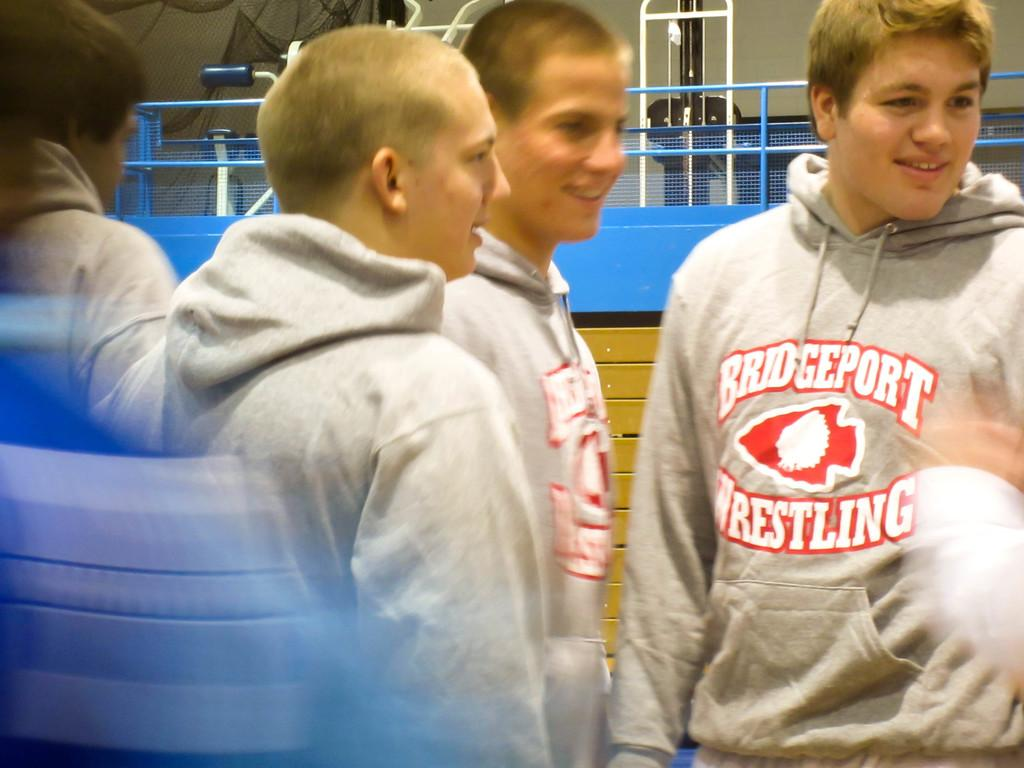Provide a one-sentence caption for the provided image. Bunch of Men wearing Bridgeport Wrestling Sweatshirts, that are smiling. 